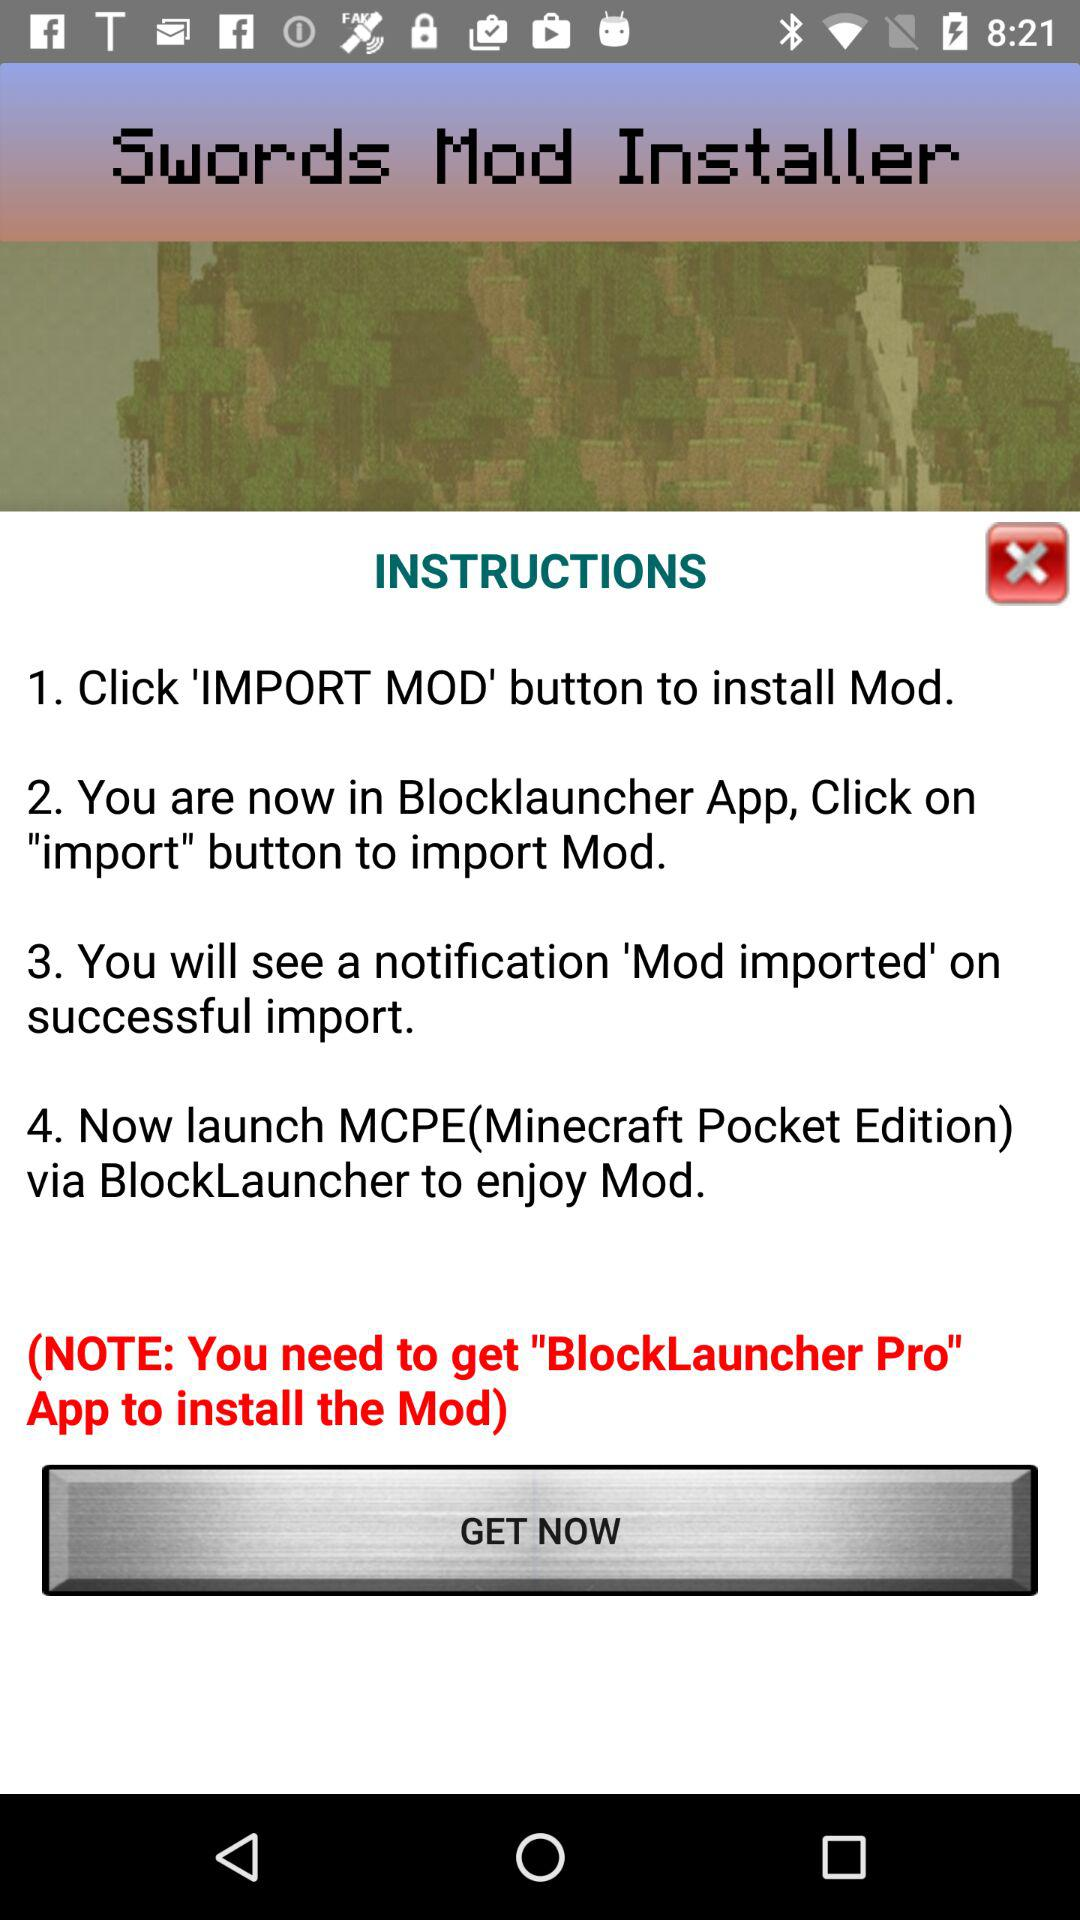What app do you need to get to install the mod? You need to get the "BlockLauncher Pro" app to install the mod. 